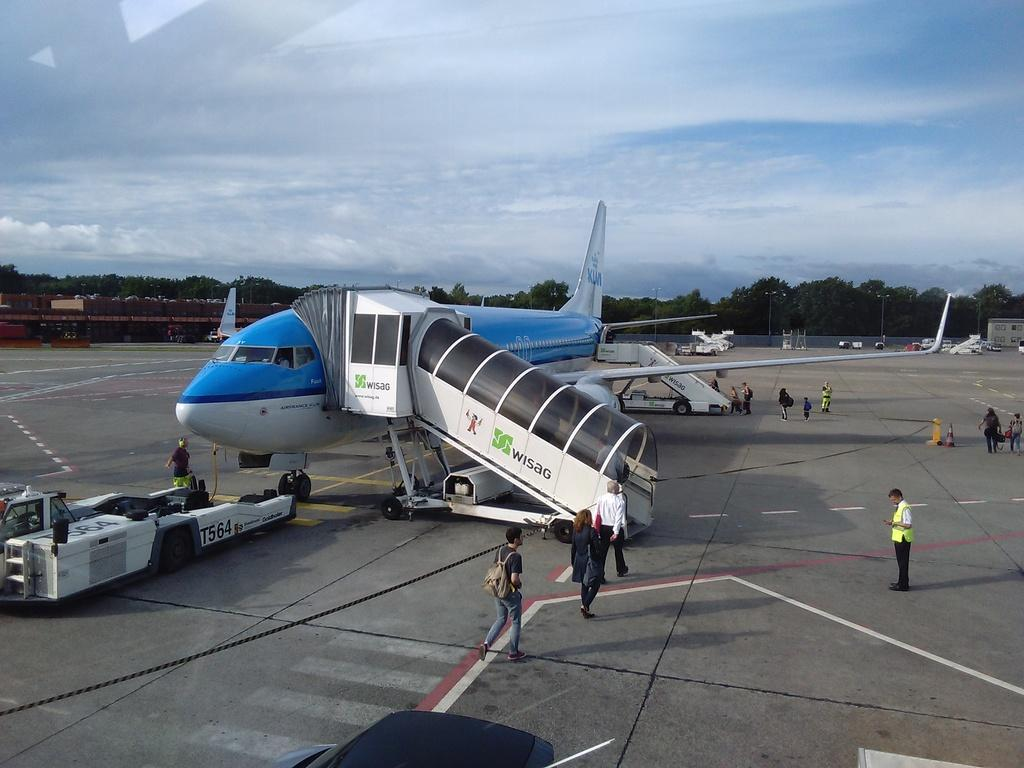<image>
Offer a succinct explanation of the picture presented. People are boarding Air France and the officer are patiently waiting for them. 